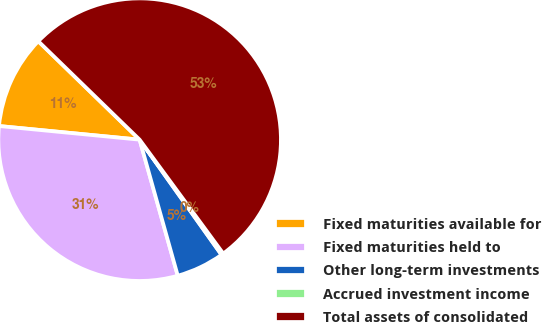Convert chart to OTSL. <chart><loc_0><loc_0><loc_500><loc_500><pie_chart><fcel>Fixed maturities available for<fcel>Fixed maturities held to<fcel>Other long-term investments<fcel>Accrued investment income<fcel>Total assets of consolidated<nl><fcel>10.73%<fcel>30.89%<fcel>5.49%<fcel>0.24%<fcel>52.65%<nl></chart> 